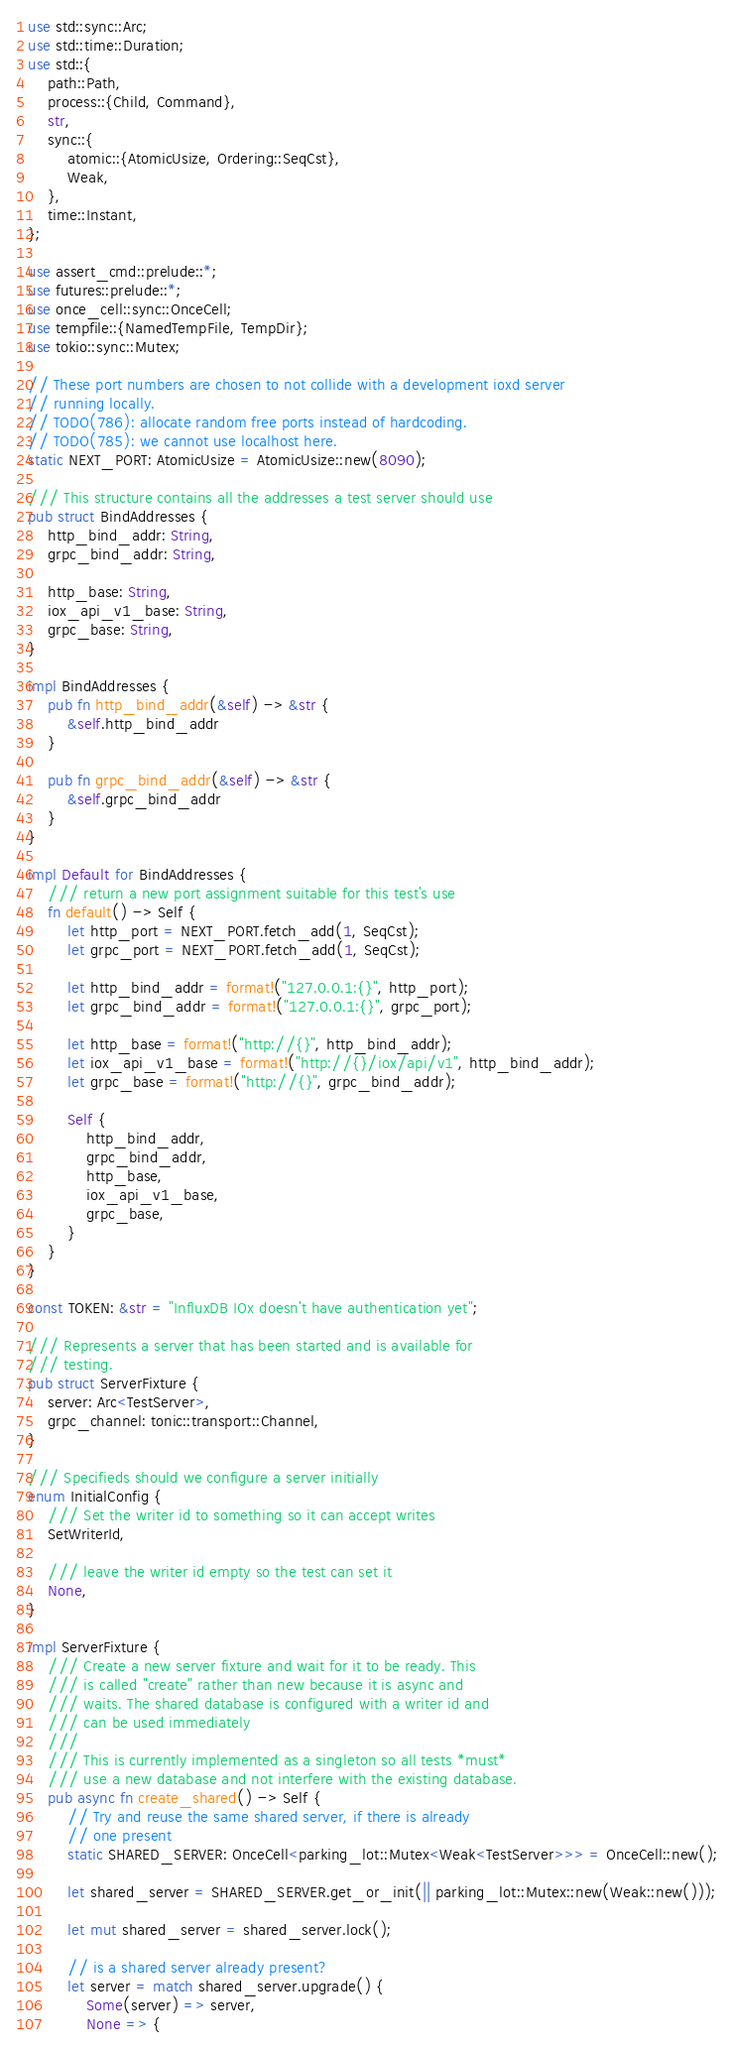Convert code to text. <code><loc_0><loc_0><loc_500><loc_500><_Rust_>use std::sync::Arc;
use std::time::Duration;
use std::{
    path::Path,
    process::{Child, Command},
    str,
    sync::{
        atomic::{AtomicUsize, Ordering::SeqCst},
        Weak,
    },
    time::Instant,
};

use assert_cmd::prelude::*;
use futures::prelude::*;
use once_cell::sync::OnceCell;
use tempfile::{NamedTempFile, TempDir};
use tokio::sync::Mutex;

// These port numbers are chosen to not collide with a development ioxd server
// running locally.
// TODO(786): allocate random free ports instead of hardcoding.
// TODO(785): we cannot use localhost here.
static NEXT_PORT: AtomicUsize = AtomicUsize::new(8090);

/// This structure contains all the addresses a test server should use
pub struct BindAddresses {
    http_bind_addr: String,
    grpc_bind_addr: String,

    http_base: String,
    iox_api_v1_base: String,
    grpc_base: String,
}

impl BindAddresses {
    pub fn http_bind_addr(&self) -> &str {
        &self.http_bind_addr
    }

    pub fn grpc_bind_addr(&self) -> &str {
        &self.grpc_bind_addr
    }
}

impl Default for BindAddresses {
    /// return a new port assignment suitable for this test's use
    fn default() -> Self {
        let http_port = NEXT_PORT.fetch_add(1, SeqCst);
        let grpc_port = NEXT_PORT.fetch_add(1, SeqCst);

        let http_bind_addr = format!("127.0.0.1:{}", http_port);
        let grpc_bind_addr = format!("127.0.0.1:{}", grpc_port);

        let http_base = format!("http://{}", http_bind_addr);
        let iox_api_v1_base = format!("http://{}/iox/api/v1", http_bind_addr);
        let grpc_base = format!("http://{}", grpc_bind_addr);

        Self {
            http_bind_addr,
            grpc_bind_addr,
            http_base,
            iox_api_v1_base,
            grpc_base,
        }
    }
}

const TOKEN: &str = "InfluxDB IOx doesn't have authentication yet";

/// Represents a server that has been started and is available for
/// testing.
pub struct ServerFixture {
    server: Arc<TestServer>,
    grpc_channel: tonic::transport::Channel,
}

/// Specifieds should we configure a server initially
enum InitialConfig {
    /// Set the writer id to something so it can accept writes
    SetWriterId,

    /// leave the writer id empty so the test can set it
    None,
}

impl ServerFixture {
    /// Create a new server fixture and wait for it to be ready. This
    /// is called "create" rather than new because it is async and
    /// waits. The shared database is configured with a writer id and
    /// can be used immediately
    ///
    /// This is currently implemented as a singleton so all tests *must*
    /// use a new database and not interfere with the existing database.
    pub async fn create_shared() -> Self {
        // Try and reuse the same shared server, if there is already
        // one present
        static SHARED_SERVER: OnceCell<parking_lot::Mutex<Weak<TestServer>>> = OnceCell::new();

        let shared_server = SHARED_SERVER.get_or_init(|| parking_lot::Mutex::new(Weak::new()));

        let mut shared_server = shared_server.lock();

        // is a shared server already present?
        let server = match shared_server.upgrade() {
            Some(server) => server,
            None => {</code> 